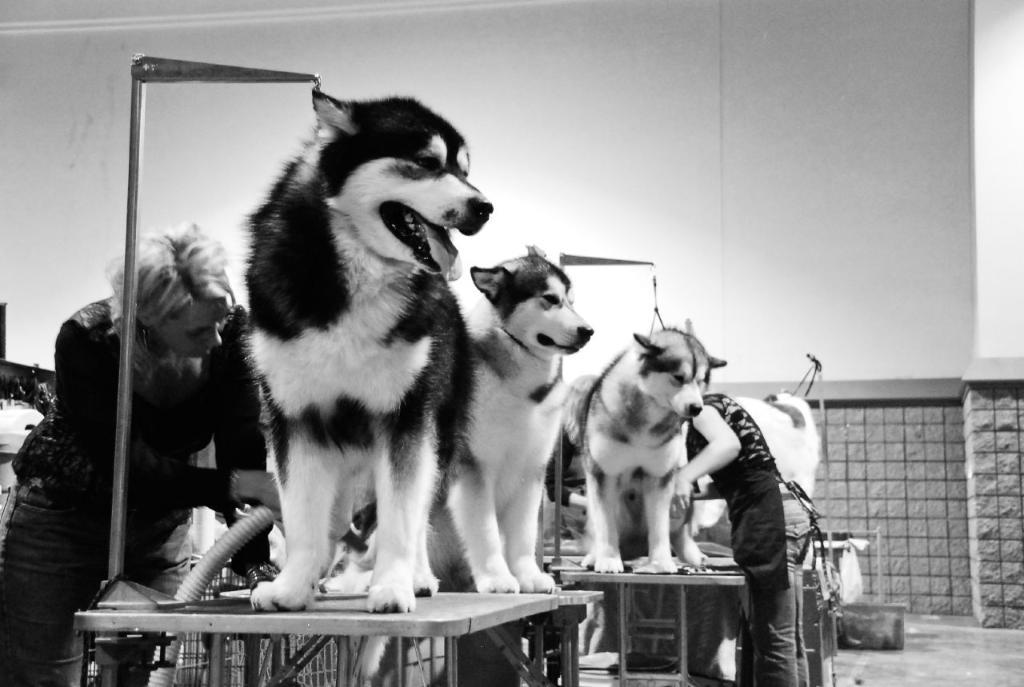What type of animals can be seen in the image? There are dogs in the image. How many people are present in the image? There are two people standing in the image. What are the people wearing? The people are wearing dresses. What can be seen in the background of the image? There is a wall in the background of the image. What is the color scheme of the image? The image is black and white. What type of design can be seen on the quicksand in the image? There is no quicksand present in the image, so it is not possible to answer that question. 